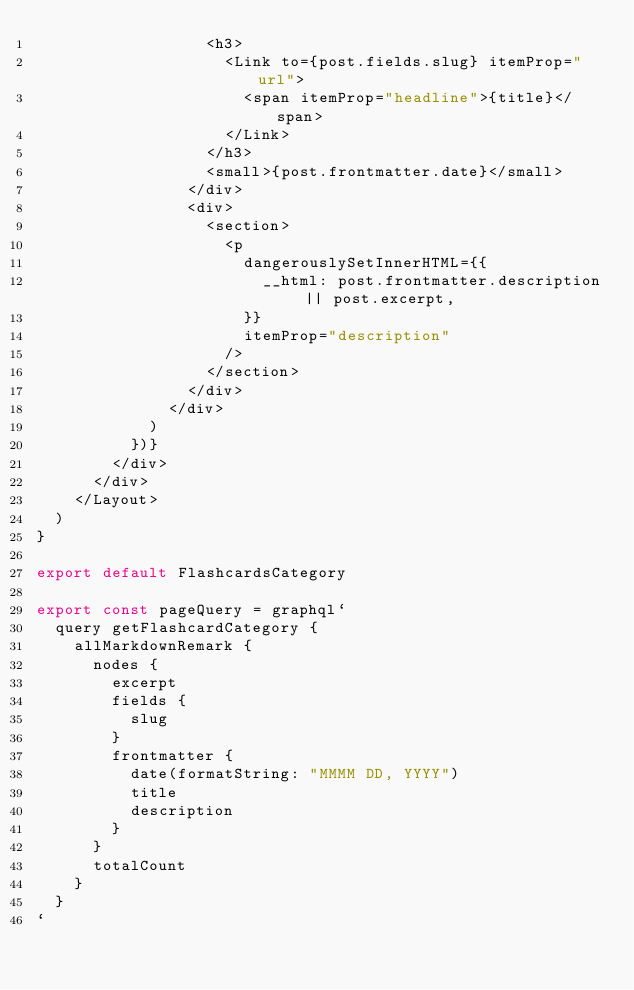<code> <loc_0><loc_0><loc_500><loc_500><_JavaScript_>                  <h3>
                    <Link to={post.fields.slug} itemProp="url">
                      <span itemProp="headline">{title}</span>
                    </Link>
                  </h3>
                  <small>{post.frontmatter.date}</small>
                </div>
                <div>
                  <section>
                    <p
                      dangerouslySetInnerHTML={{
                        __html: post.frontmatter.description || post.excerpt,
                      }}
                      itemProp="description"
                    />
                  </section>
                </div>
              </div>
            )
          })}
        </div>
      </div>
    </Layout>
  )
}

export default FlashcardsCategory

export const pageQuery = graphql`
  query getFlashcardCategory {
    allMarkdownRemark {
      nodes {
        excerpt
        fields {
          slug
        }
        frontmatter {
          date(formatString: "MMMM DD, YYYY")
          title
          description
        }
      }
      totalCount
    }
  }
`
</code> 